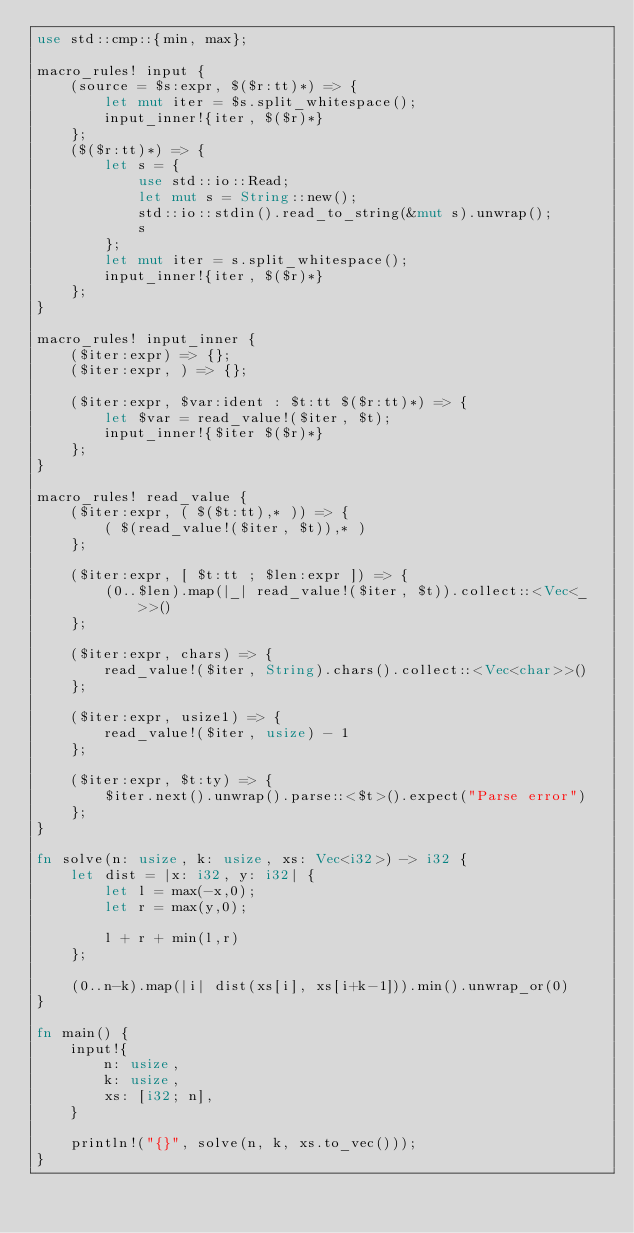<code> <loc_0><loc_0><loc_500><loc_500><_Rust_>use std::cmp::{min, max};

macro_rules! input {
    (source = $s:expr, $($r:tt)*) => {
        let mut iter = $s.split_whitespace();
        input_inner!{iter, $($r)*}
    };
    ($($r:tt)*) => {
        let s = {
            use std::io::Read;
            let mut s = String::new();
            std::io::stdin().read_to_string(&mut s).unwrap();
            s
        };
        let mut iter = s.split_whitespace();
        input_inner!{iter, $($r)*}
    };
}

macro_rules! input_inner {
    ($iter:expr) => {};
    ($iter:expr, ) => {};

    ($iter:expr, $var:ident : $t:tt $($r:tt)*) => {
        let $var = read_value!($iter, $t);
        input_inner!{$iter $($r)*}
    };
}

macro_rules! read_value {
    ($iter:expr, ( $($t:tt),* )) => {
        ( $(read_value!($iter, $t)),* )
    };

    ($iter:expr, [ $t:tt ; $len:expr ]) => {
        (0..$len).map(|_| read_value!($iter, $t)).collect::<Vec<_>>()
    };

    ($iter:expr, chars) => {
        read_value!($iter, String).chars().collect::<Vec<char>>()
    };

    ($iter:expr, usize1) => {
        read_value!($iter, usize) - 1
    };

    ($iter:expr, $t:ty) => {
        $iter.next().unwrap().parse::<$t>().expect("Parse error")
    };
}

fn solve(n: usize, k: usize, xs: Vec<i32>) -> i32 {
    let dist = |x: i32, y: i32| {
        let l = max(-x,0);
        let r = max(y,0);

        l + r + min(l,r)
    };

    (0..n-k).map(|i| dist(xs[i], xs[i+k-1])).min().unwrap_or(0)
}

fn main() {
    input!{
        n: usize,
        k: usize,
        xs: [i32; n],
    }

    println!("{}", solve(n, k, xs.to_vec()));
}
</code> 